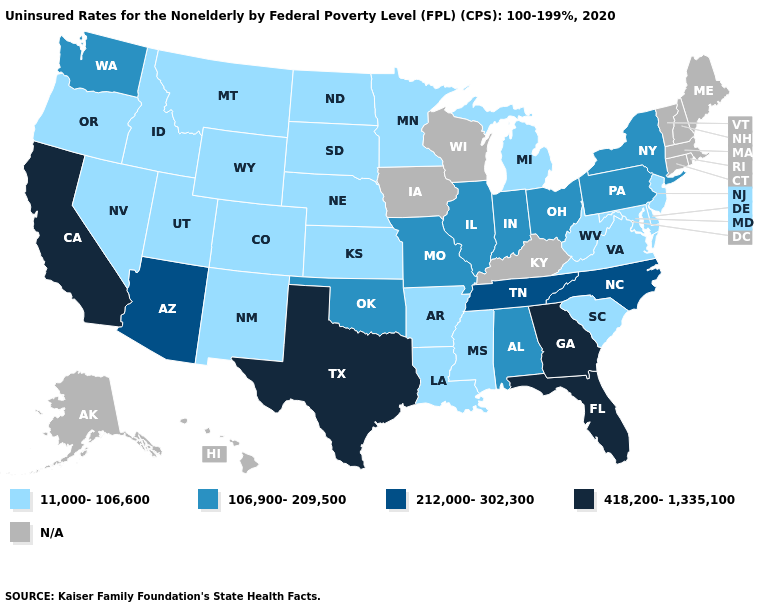Which states have the highest value in the USA?
Quick response, please. California, Florida, Georgia, Texas. What is the value of Wisconsin?
Answer briefly. N/A. Does the map have missing data?
Answer briefly. Yes. Is the legend a continuous bar?
Short answer required. No. What is the value of North Dakota?
Be succinct. 11,000-106,600. Does the first symbol in the legend represent the smallest category?
Keep it brief. Yes. What is the value of Wisconsin?
Answer briefly. N/A. Name the states that have a value in the range 11,000-106,600?
Answer briefly. Arkansas, Colorado, Delaware, Idaho, Kansas, Louisiana, Maryland, Michigan, Minnesota, Mississippi, Montana, Nebraska, Nevada, New Jersey, New Mexico, North Dakota, Oregon, South Carolina, South Dakota, Utah, Virginia, West Virginia, Wyoming. Name the states that have a value in the range 212,000-302,300?
Keep it brief. Arizona, North Carolina, Tennessee. What is the value of Missouri?
Short answer required. 106,900-209,500. What is the value of Maine?
Be succinct. N/A. Among the states that border Arizona , does California have the highest value?
Short answer required. Yes. Name the states that have a value in the range 418,200-1,335,100?
Quick response, please. California, Florida, Georgia, Texas. 